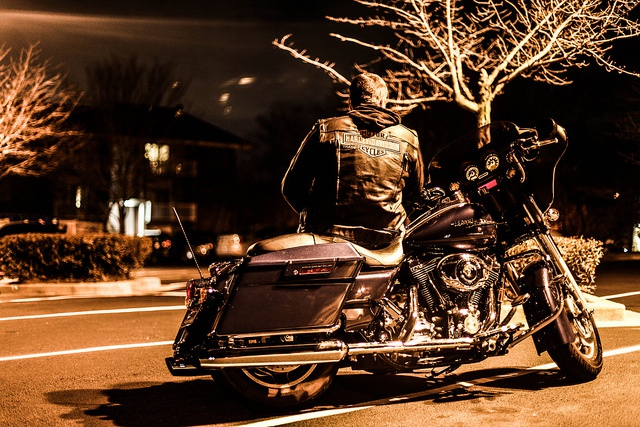Describe the objects in this image and their specific colors. I can see motorcycle in maroon, black, brown, and tan tones and people in maroon, black, brown, and tan tones in this image. 